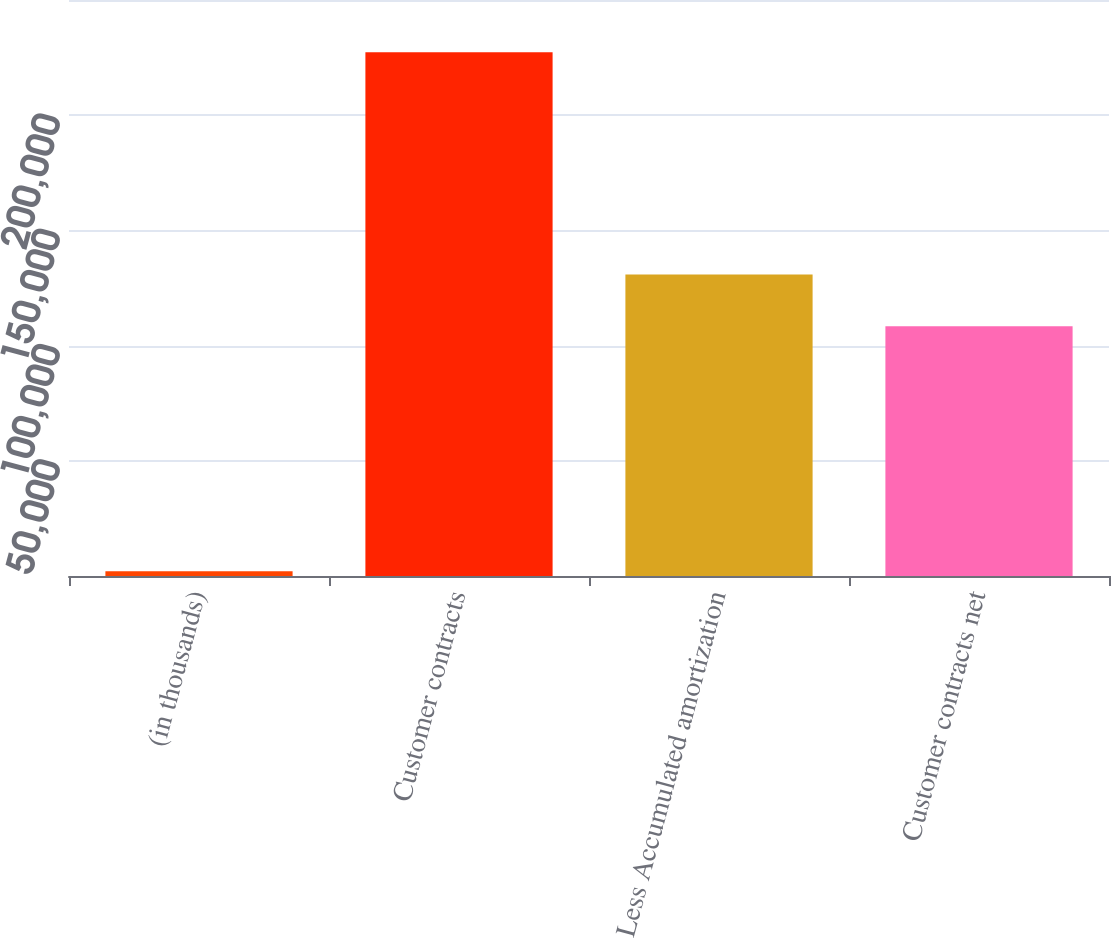Convert chart to OTSL. <chart><loc_0><loc_0><loc_500><loc_500><bar_chart><fcel>(in thousands)<fcel>Customer contracts<fcel>Less Accumulated amortization<fcel>Customer contracts net<nl><fcel>2011<fcel>227281<fcel>130875<fcel>108348<nl></chart> 